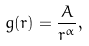<formula> <loc_0><loc_0><loc_500><loc_500>g ( r ) = \frac { A } { r ^ { \alpha } } ,</formula> 